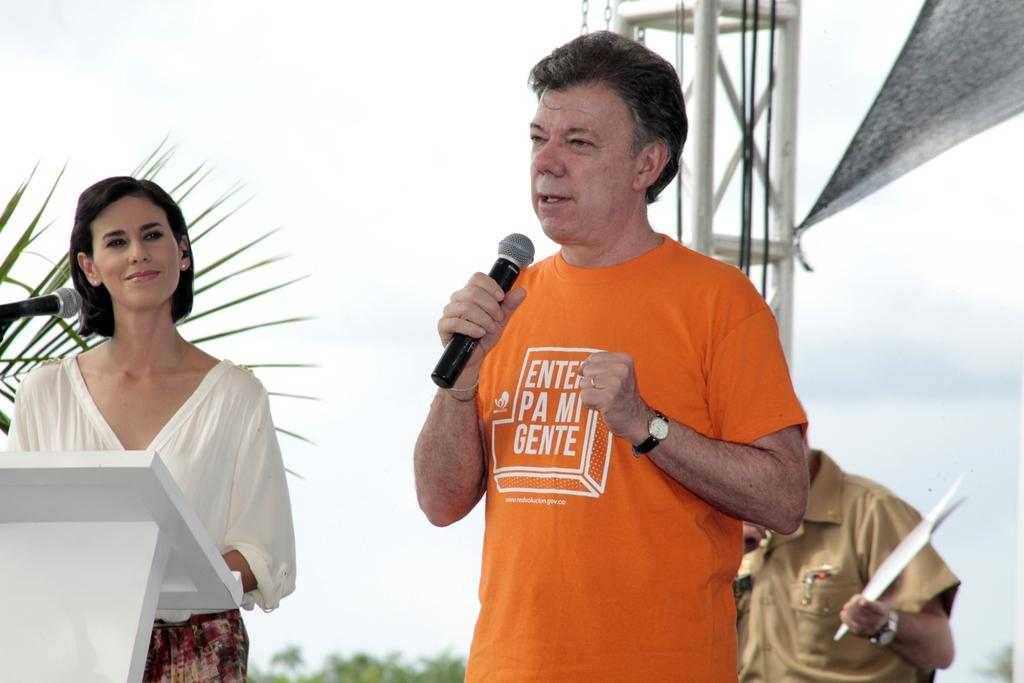How many people are present in the image? There are two people in the image. What is one person doing in the image? One person is speaking into a microphone. How is the other person reacting to the speaker? The other person is staring at the speaker and smiling. What color is the blood on the microphone in the image? There is no blood present on the microphone or in the image. 